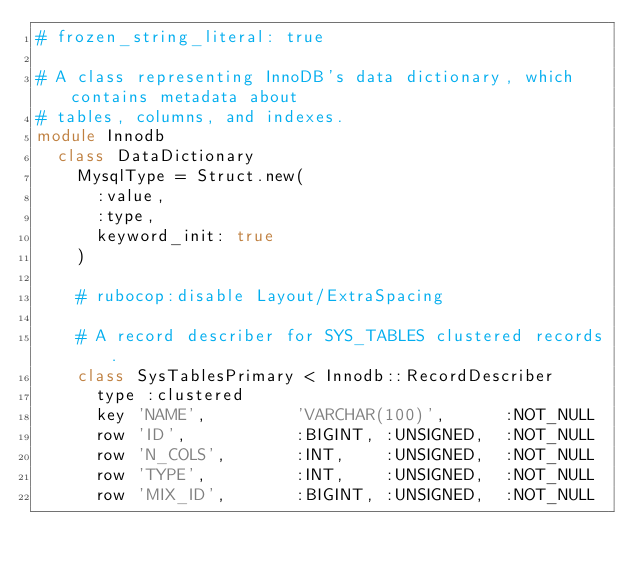<code> <loc_0><loc_0><loc_500><loc_500><_Ruby_># frozen_string_literal: true

# A class representing InnoDB's data dictionary, which contains metadata about
# tables, columns, and indexes.
module Innodb
  class DataDictionary
    MysqlType = Struct.new(
      :value,
      :type,
      keyword_init: true
    )

    # rubocop:disable Layout/ExtraSpacing

    # A record describer for SYS_TABLES clustered records.
    class SysTablesPrimary < Innodb::RecordDescriber
      type :clustered
      key 'NAME',         'VARCHAR(100)',      :NOT_NULL
      row 'ID',           :BIGINT, :UNSIGNED,  :NOT_NULL
      row 'N_COLS',       :INT,    :UNSIGNED,  :NOT_NULL
      row 'TYPE',         :INT,    :UNSIGNED,  :NOT_NULL
      row 'MIX_ID',       :BIGINT, :UNSIGNED,  :NOT_NULL</code> 